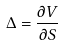<formula> <loc_0><loc_0><loc_500><loc_500>\Delta = \frac { \partial V } { \partial S }</formula> 